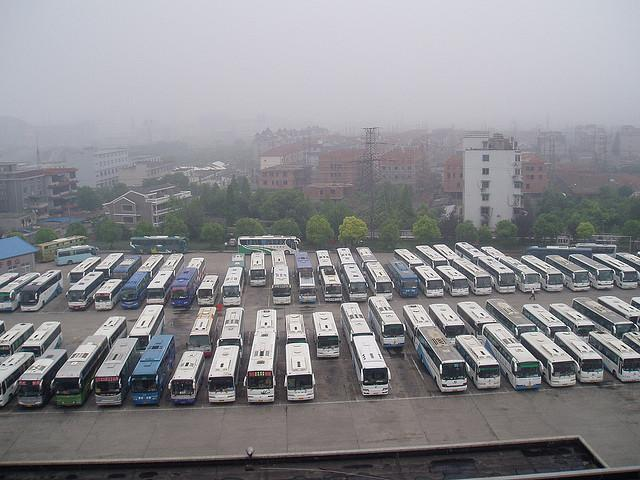What type of lot is this?

Choices:
A) fairground
B) bus depot
C) used car
D) new car bus depot 